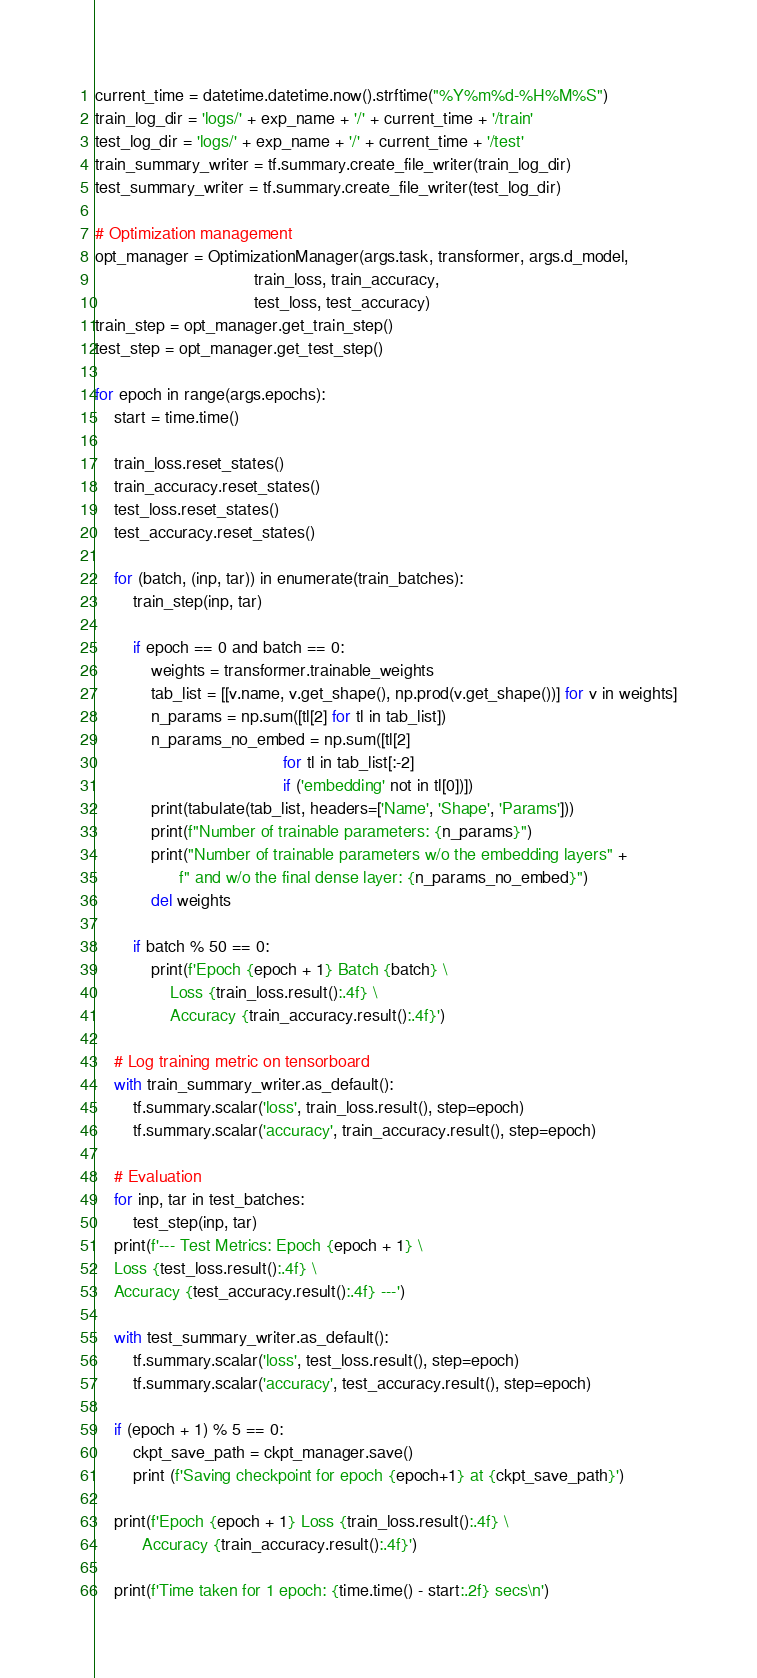<code> <loc_0><loc_0><loc_500><loc_500><_Python_>current_time = datetime.datetime.now().strftime("%Y%m%d-%H%M%S")
train_log_dir = 'logs/' + exp_name + '/' + current_time + '/train'
test_log_dir = 'logs/' + exp_name + '/' + current_time + '/test'
train_summary_writer = tf.summary.create_file_writer(train_log_dir)
test_summary_writer = tf.summary.create_file_writer(test_log_dir)

# Optimization management
opt_manager = OptimizationManager(args.task, transformer, args.d_model,
                                  train_loss, train_accuracy,
                                  test_loss, test_accuracy)
train_step = opt_manager.get_train_step()
test_step = opt_manager.get_test_step()

for epoch in range(args.epochs):
    start = time.time()

    train_loss.reset_states()
    train_accuracy.reset_states()
    test_loss.reset_states()
    test_accuracy.reset_states()

    for (batch, (inp, tar)) in enumerate(train_batches):
        train_step(inp, tar)

        if epoch == 0 and batch == 0:
            weights = transformer.trainable_weights
            tab_list = [[v.name, v.get_shape(), np.prod(v.get_shape())] for v in weights]
            n_params = np.sum([tl[2] for tl in tab_list])
            n_params_no_embed = np.sum([tl[2]
                                        for tl in tab_list[:-2]
                                        if ('embedding' not in tl[0])])
            print(tabulate(tab_list, headers=['Name', 'Shape', 'Params']))
            print(f"Number of trainable parameters: {n_params}")
            print("Number of trainable parameters w/o the embedding layers" +
                  f" and w/o the final dense layer: {n_params_no_embed}")
            del weights

        if batch % 50 == 0:
            print(f'Epoch {epoch + 1} Batch {batch} \
                Loss {train_loss.result():.4f} \
                Accuracy {train_accuracy.result():.4f}')

    # Log training metric on tensorboard
    with train_summary_writer.as_default():
        tf.summary.scalar('loss', train_loss.result(), step=epoch)
        tf.summary.scalar('accuracy', train_accuracy.result(), step=epoch)

    # Evaluation
    for inp, tar in test_batches:
        test_step(inp, tar)
    print(f'--- Test Metrics: Epoch {epoch + 1} \
    Loss {test_loss.result():.4f} \
    Accuracy {test_accuracy.result():.4f} ---')

    with test_summary_writer.as_default():
        tf.summary.scalar('loss', test_loss.result(), step=epoch)
        tf.summary.scalar('accuracy', test_accuracy.result(), step=epoch)

    if (epoch + 1) % 5 == 0:
        ckpt_save_path = ckpt_manager.save()
        print (f'Saving checkpoint for epoch {epoch+1} at {ckpt_save_path}')

    print(f'Epoch {epoch + 1} Loss {train_loss.result():.4f} \
          Accuracy {train_accuracy.result():.4f}')

    print(f'Time taken for 1 epoch: {time.time() - start:.2f} secs\n')
</code> 